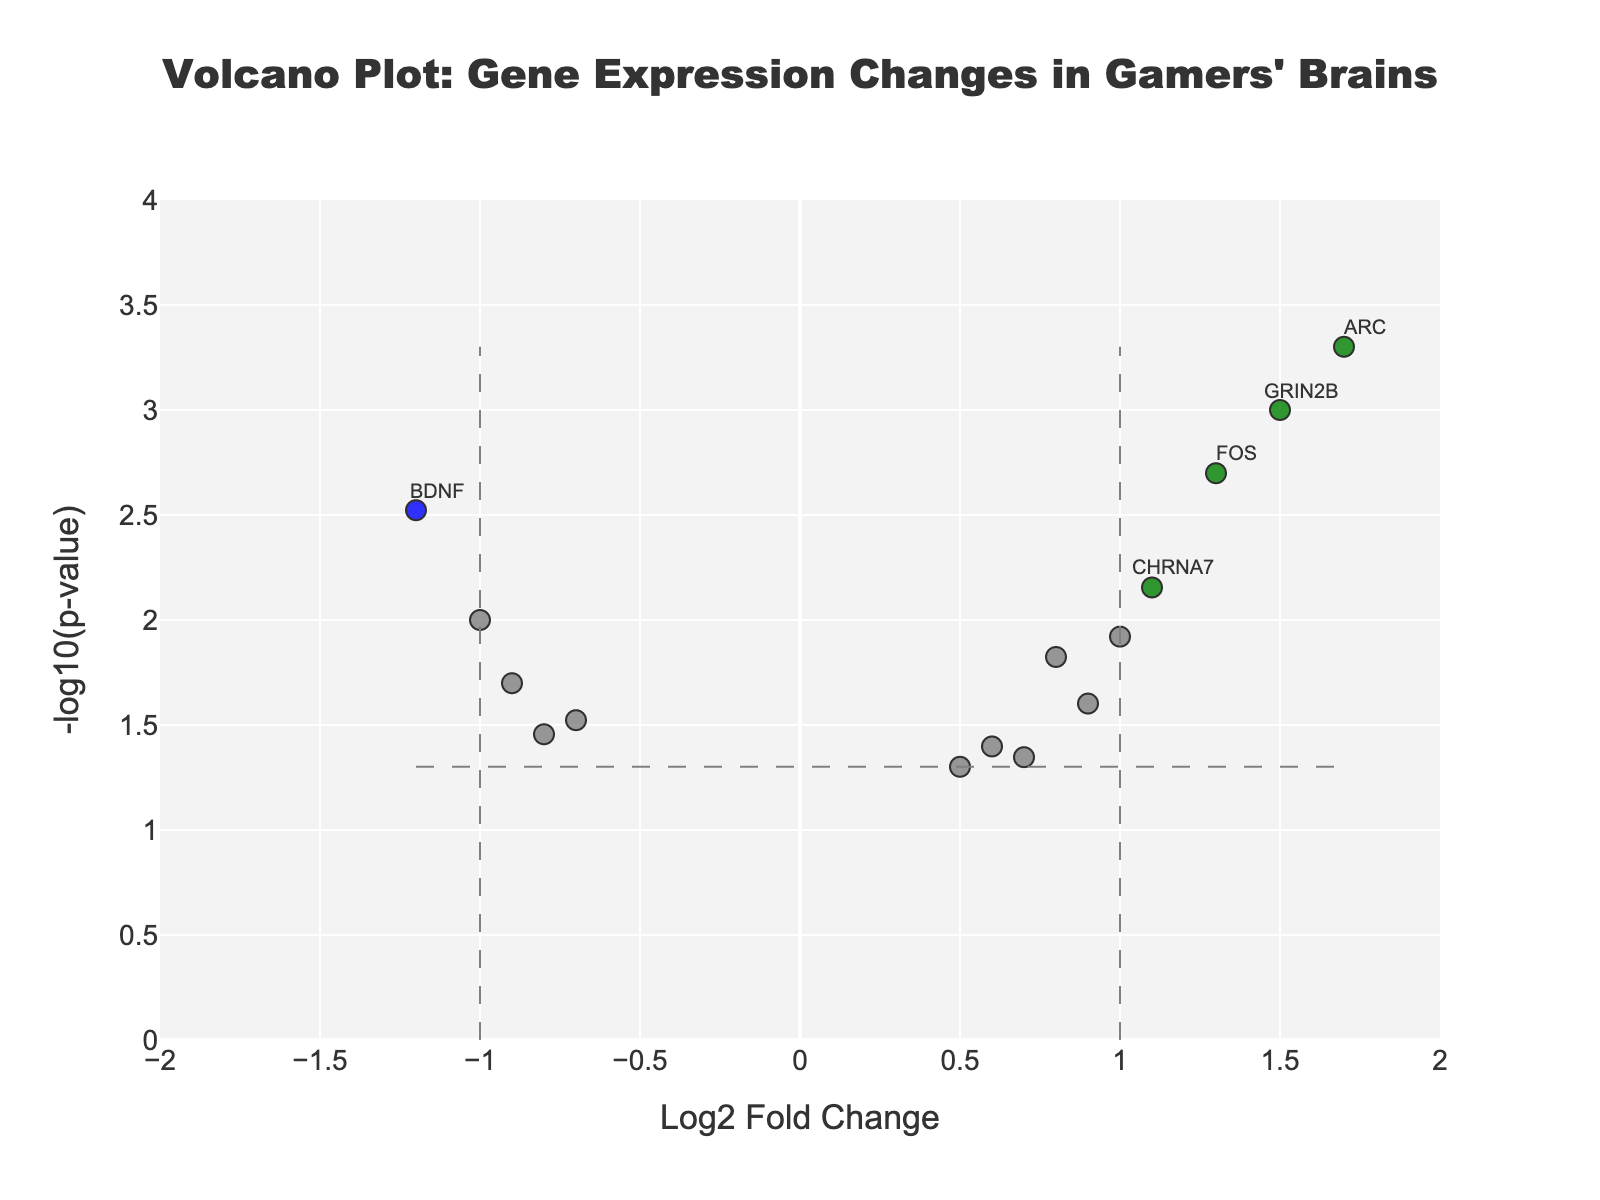What is the title of the plot? The title of the plot is typically located at the top and is used to describe the dataset and purpose of the graph. In this case, it reads "Volcano Plot: Gene Expression Changes in Gamers' Brains" which indicates that the plot shows gene expression changes in gamers' brains.
Answer: Volcano Plot: Gene Expression Changes in Gamers' Brains Which gene has the highest fold change? To find the gene with the highest fold change, look at the x-axis for the point farthest to the right, which corresponds to the highest log2 fold change. Then check the label next to this point.
Answer: ARC How many genes have a p-value less than 0.05 and an absolute fold change greater than 1? Look at the points that are colored (red, blue, green) since they represent genes with p-values < 0.05 and
Answer: There are 5 genes with significant changes as indicated by their colored dots What are the x-axis and y-axis labels? The labels of the x-axis and y-axis indicate what kind of data is being represented. In this plot, the x-axis represents "Log2 Fold Change" and the y-axis represents "-log10(p-value)".
Answer: Log2 Fold Change (x-axis), -log10(p-value) (y-axis) Which genes are significantly downregulated? Look for the genes that are highlighted in blue, this indicates significant downregulation with an absolute fold change greater than 1 and p-value < 0.05. Check the labels next to these points.
Answer: BDNF, SLC6A3, NPY What gene has the lowest p-value? The lowest p-value corresponds to the highest point along the y-axis. Identify the highest point and read its label.
Answer: ARC Which gene shows the highest upregulation with a fold change greater than 1? To determine this, identify the green dot farthest to the right along the x-axis and its associated label as this shows the highest significant upregulation.
Answer: ARC How many genes have log2 fold changes between -1 and 1 and p-values below 0.05? Identify the genes represented by points within the x-axis range of -1 to 1 and with y-values greater than -log10(0.05), which are not colored grey. Count these points.
Answer: There are 4 genes in this category Is HTR2A significantly up or downregulated? To determine if HTR2A is significantly up- or downregulated, find its position on the plot. Since it is located at a negative x-value within the range for significant downregulation, it is downregulated.
Answer: Downregulated 